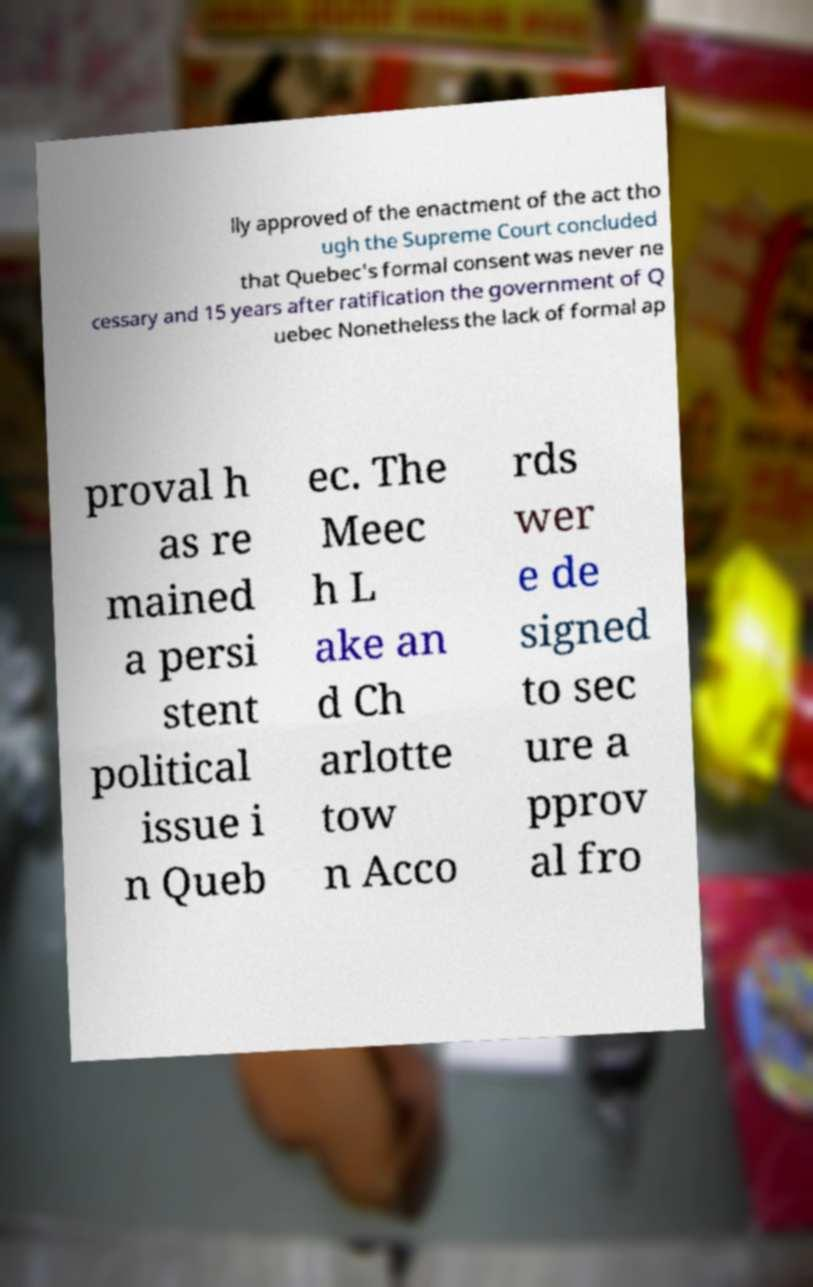Please read and relay the text visible in this image. What does it say? lly approved of the enactment of the act tho ugh the Supreme Court concluded that Quebec's formal consent was never ne cessary and 15 years after ratification the government of Q uebec Nonetheless the lack of formal ap proval h as re mained a persi stent political issue i n Queb ec. The Meec h L ake an d Ch arlotte tow n Acco rds wer e de signed to sec ure a pprov al fro 